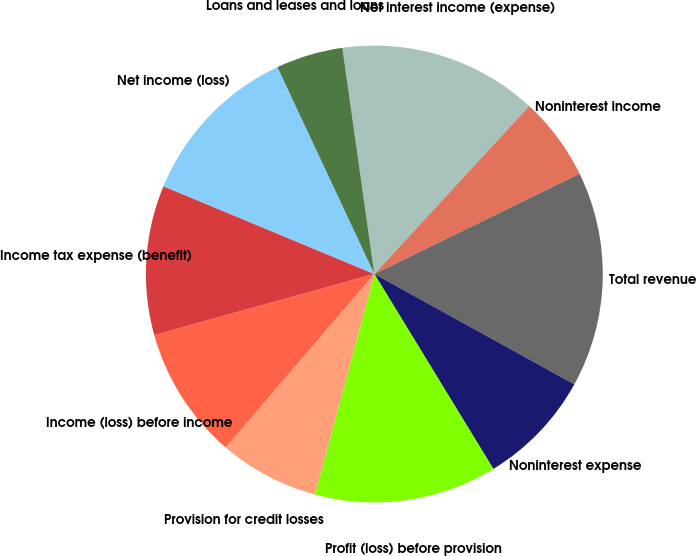Convert chart to OTSL. <chart><loc_0><loc_0><loc_500><loc_500><pie_chart><fcel>Net interest income (expense)<fcel>Noninterest income<fcel>Total revenue<fcel>Noninterest expense<fcel>Profit (loss) before provision<fcel>Provision for credit losses<fcel>Income (loss) before income<fcel>Income tax expense (benefit)<fcel>Net income (loss)<fcel>Loans and leases and loans<nl><fcel>14.09%<fcel>5.91%<fcel>15.26%<fcel>8.25%<fcel>12.92%<fcel>7.08%<fcel>9.42%<fcel>10.58%<fcel>11.75%<fcel>4.74%<nl></chart> 